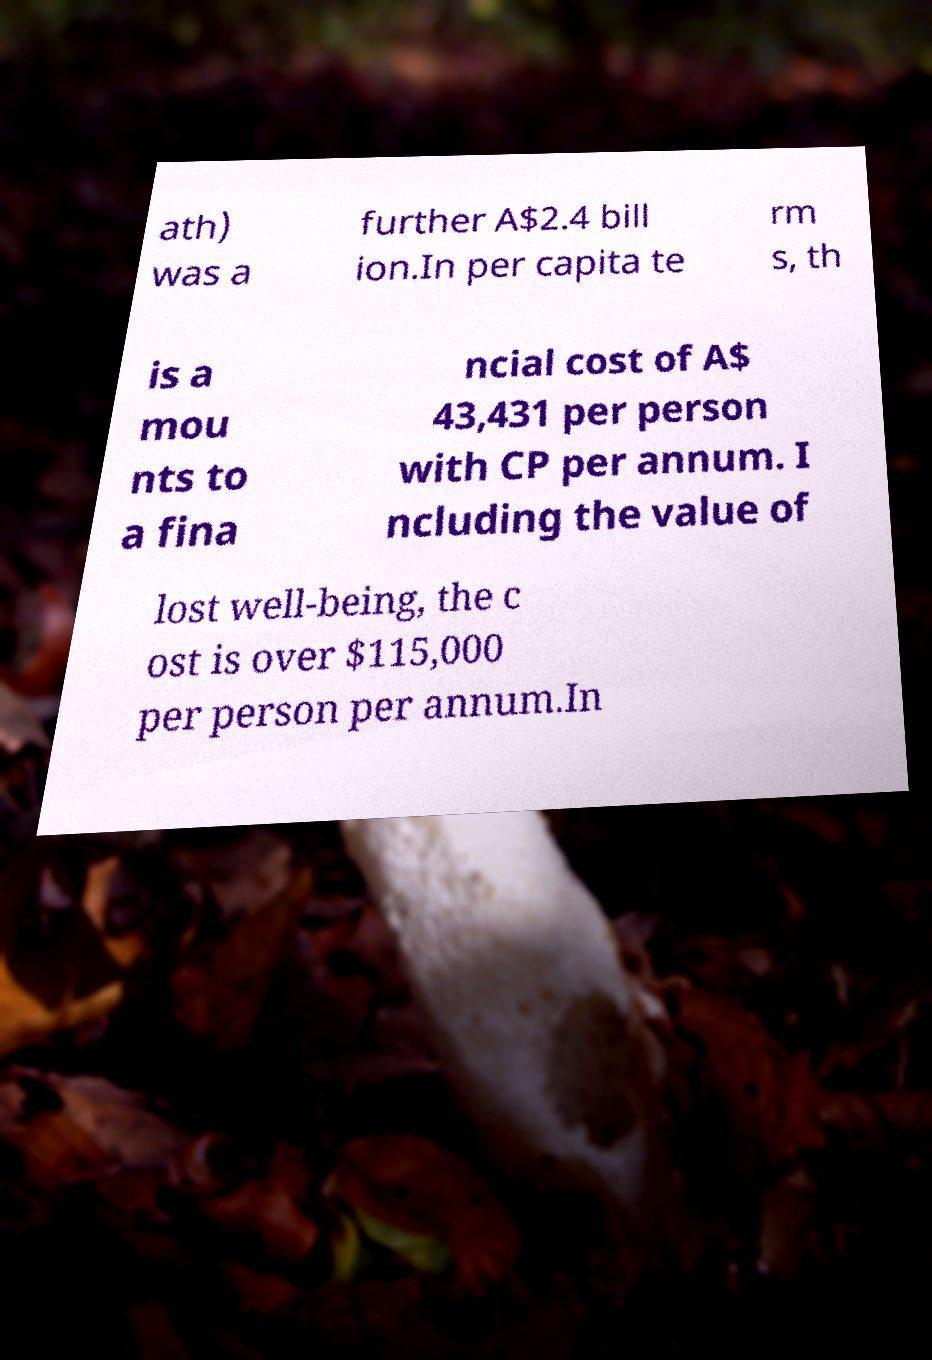Please identify and transcribe the text found in this image. ath) was a further A$2.4 bill ion.In per capita te rm s, th is a mou nts to a fina ncial cost of A$ 43,431 per person with CP per annum. I ncluding the value of lost well-being, the c ost is over $115,000 per person per annum.In 